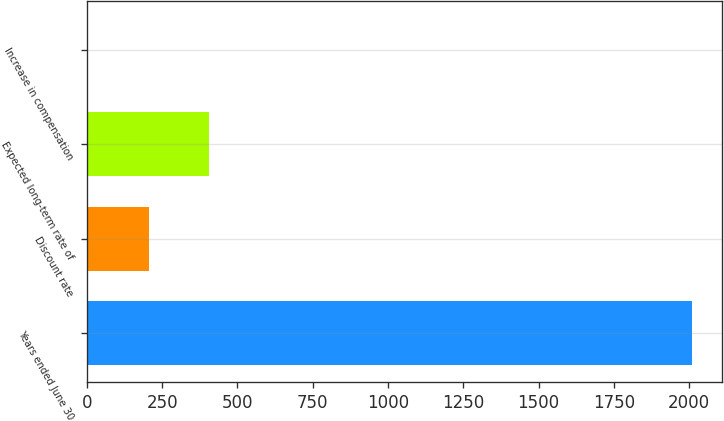<chart> <loc_0><loc_0><loc_500><loc_500><bar_chart><fcel>Years ended June 30<fcel>Discount rate<fcel>Expected long-term rate of<fcel>Increase in compensation<nl><fcel>2008<fcel>205.75<fcel>406<fcel>5.5<nl></chart> 